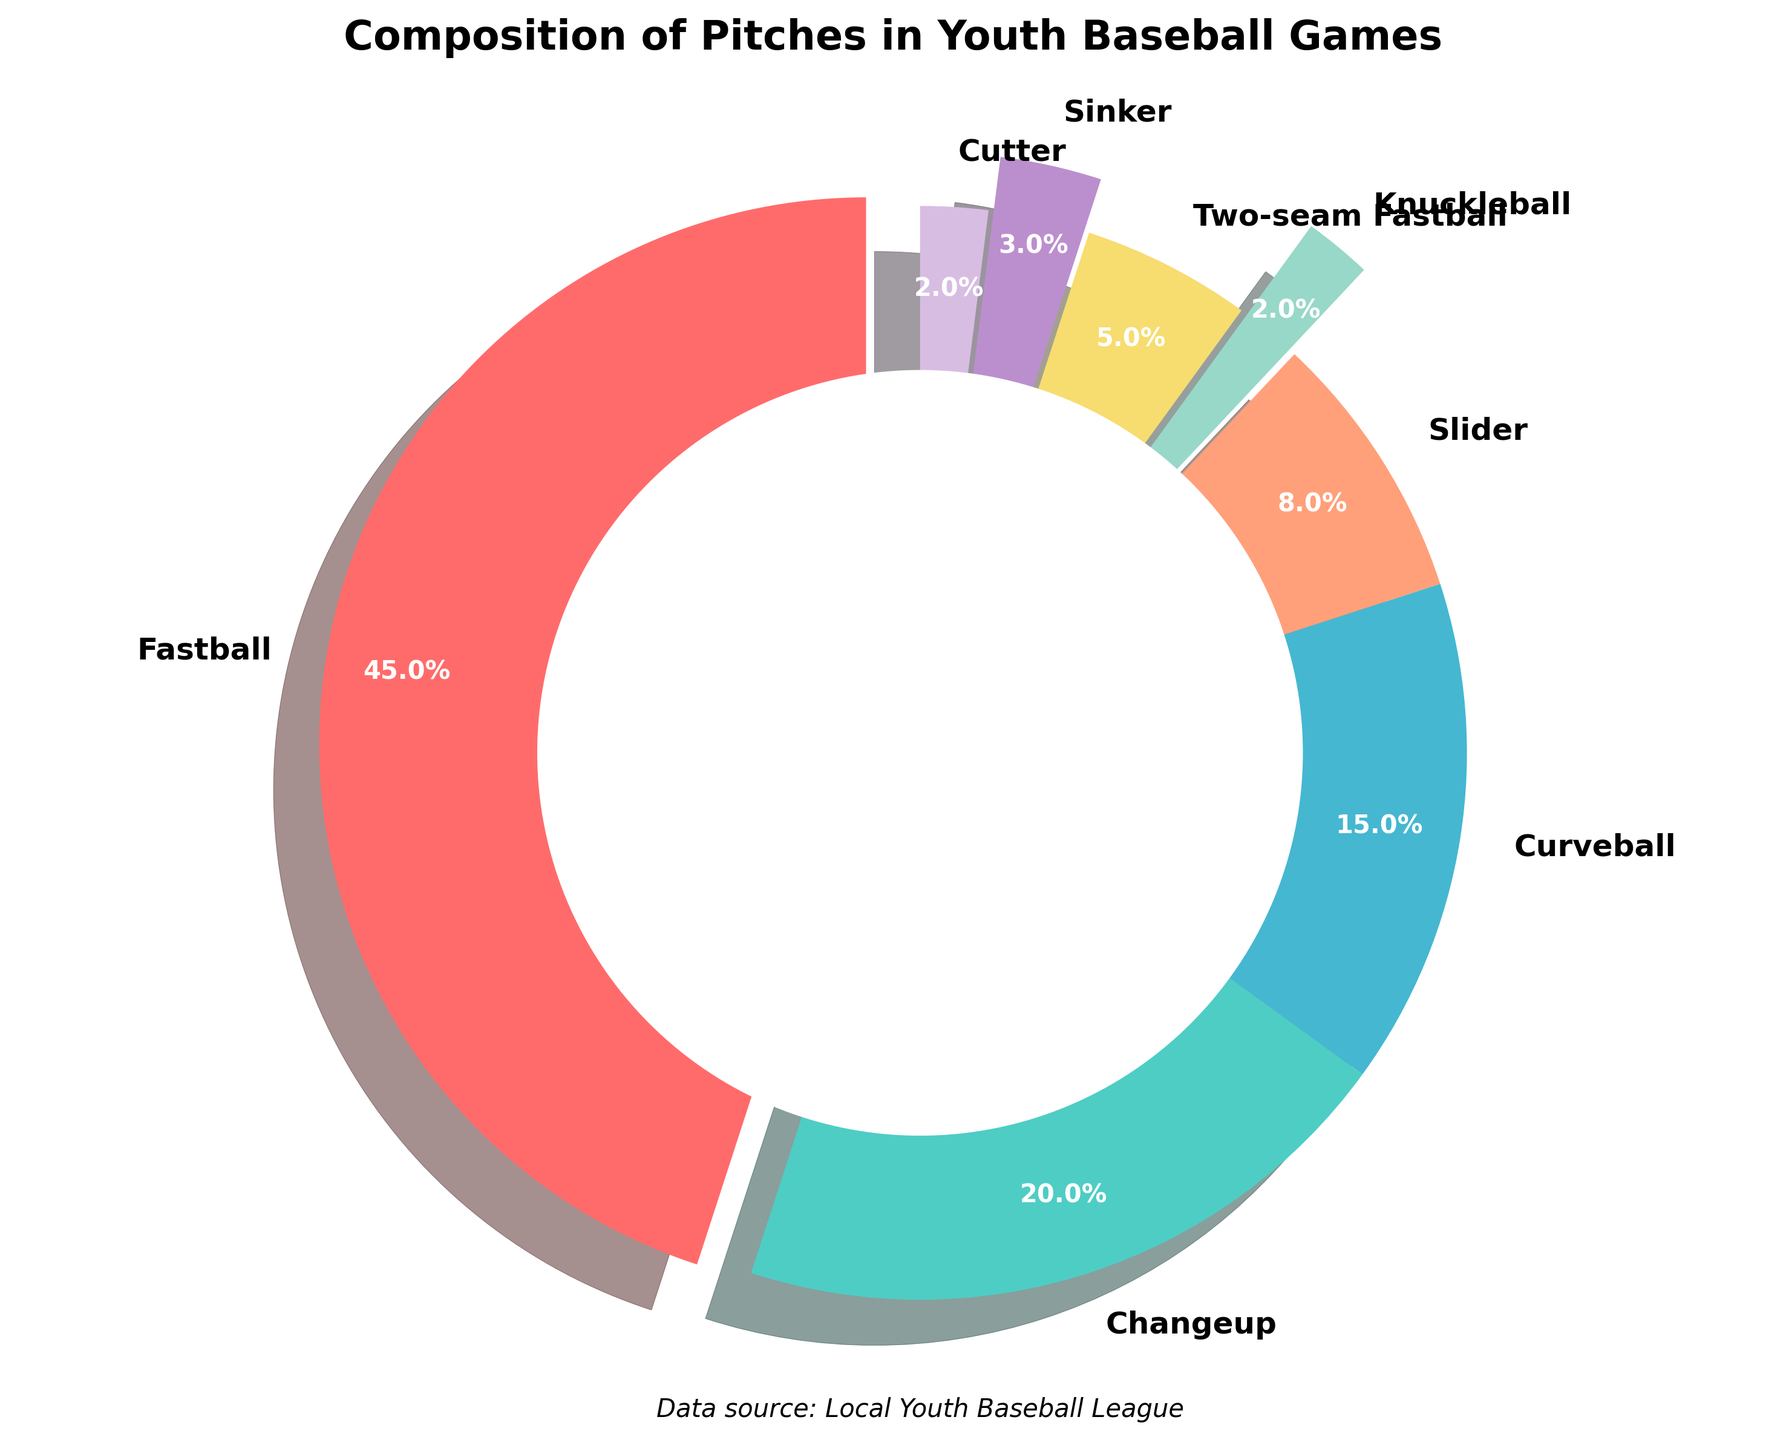What are the top three most common types of pitches? By looking at the pie chart, the three largest sections represent the most common types. Fastball, Changeup, and Curveball have the largest percentages.
Answer: Fastball, Changeup, Curveball What is the combined percentage of Sinker, Cutter, and Knuckleball pitches? To find the combined percentage, sum the individual percentages: Sinker (3%), Cutter (2%), and Knuckleball (2%). 3 + 2 + 2 = 7
Answer: 7% Which pitch type has the lowest percentage? The smallest segment in the pie chart represents the type with the lowest percentage. It is the Knuckleball at 2%.
Answer: Knuckleball How much larger is the percentage of Fastballs compared to Curveballs? Subtract the percentage of Curveballs from the percentage of Fastballs. Fastballs are 45% and Curveballs are 15%. 45 - 15 = 30
Answer: 30% Which color represents the Changeup pitches? The segment color representing Changeup is listed as the second one in the color array, which is a shade of green.
Answer: Green What percentage of pitches are either Sliders or Two-seam Fastballs? Add the percentages of Sliders (8%) and Two-seam Fastballs (5%). 8 + 5 = 13
Answer: 13% Is the percentage of Changeup pitches greater than or less than double the percentage of Sliders? Double the percentage of Sliders (8%) is 16%. Compare this to the percentage of Changeup pitches (20%). 20 > 16
Answer: Greater than What visual attribute distinguishes the Fastball section of the chart? The Fastball section is slightly exploded outwards from the center, indicating its importance.
Answer: Exploded section Which two pitch types are represented with the same percentage? The chart shows both Cutter and Knuckleball with the same percentage of 2%.
Answer: Cutter, Knuckleball What is the second least common pitch type? By looking at the second smallest segment in the pie chart, the next least common pitch after Knuckleball (2%) is Cutter (2%).
Answer: Cutter 